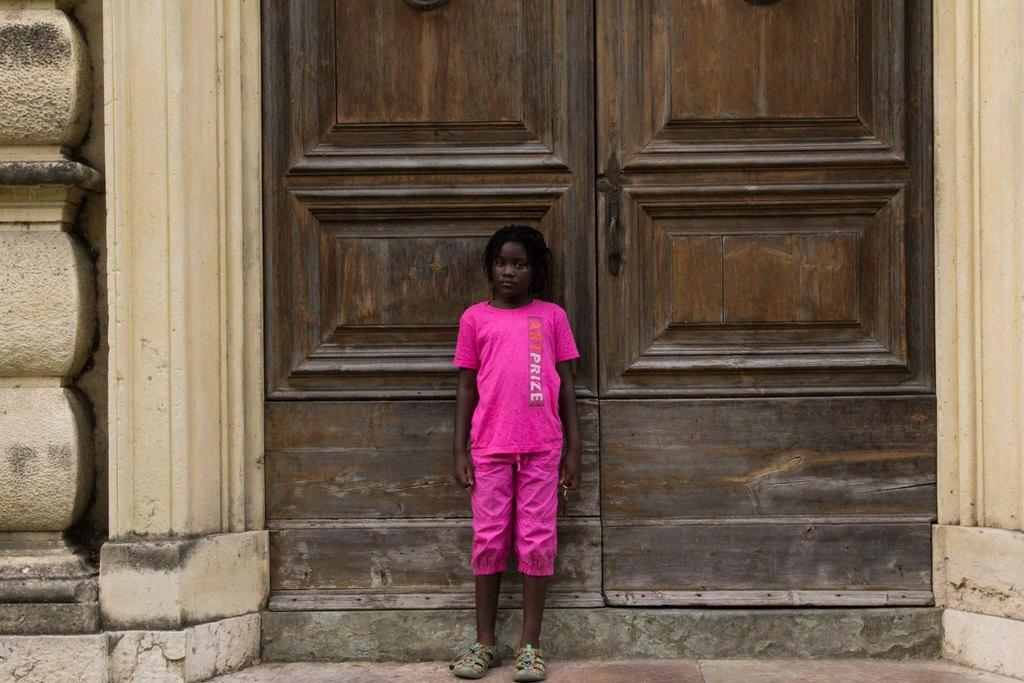What is the main subject of the image? There is a person standing in the image. Can you describe the person's attire? The person is wearing footwear and pink-colored clothes. What can be seen in the background of the image? There is a double door in the background of the image. How does the person contribute to reducing pollution in the image? There is no information about pollution or the person's actions to reduce it in the image. 